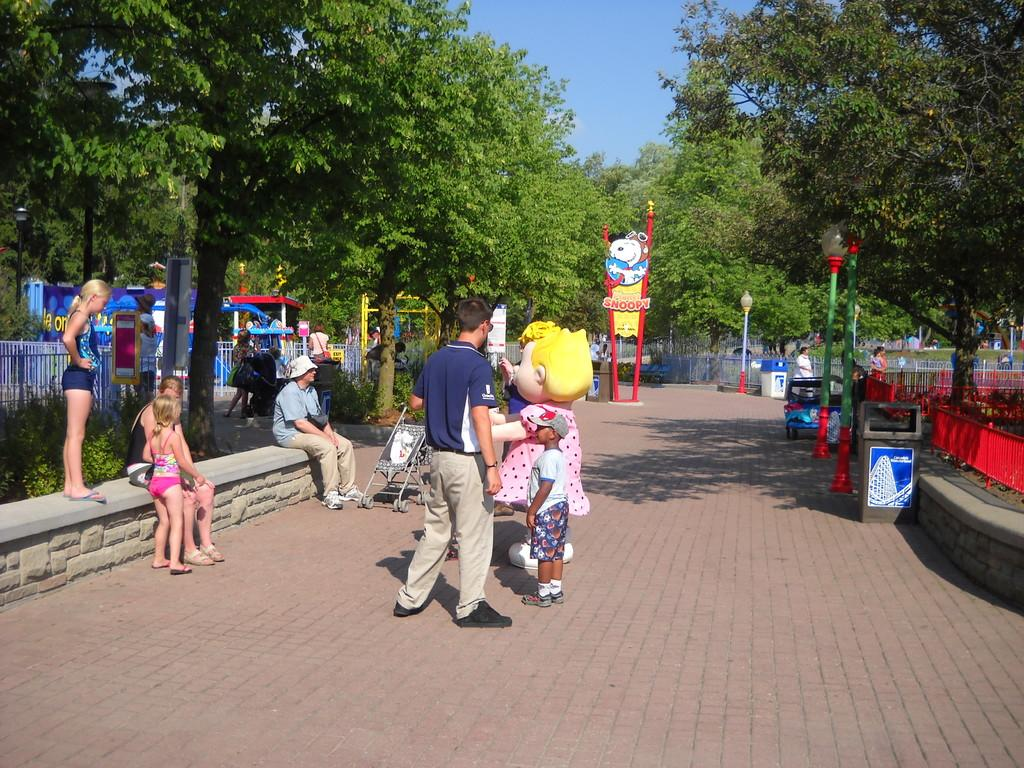What are the people in the image doing? The people in the image are standing on a pavement. What else can be seen beside the people standing on the pavement? There is a doll beside the people standing on the pavement. Are there any other people in the image? Yes, there are people sitting on a bench in the image. What can be seen on either side of the pavement? There are poles on either side of the pavement in the image. What type of brick is used to construct the field in the image? There is no field present in the image, and therefore no bricks can be observed. Can you see a crown on the doll's head in the image? There is no crown visible on the doll's head in the image. 